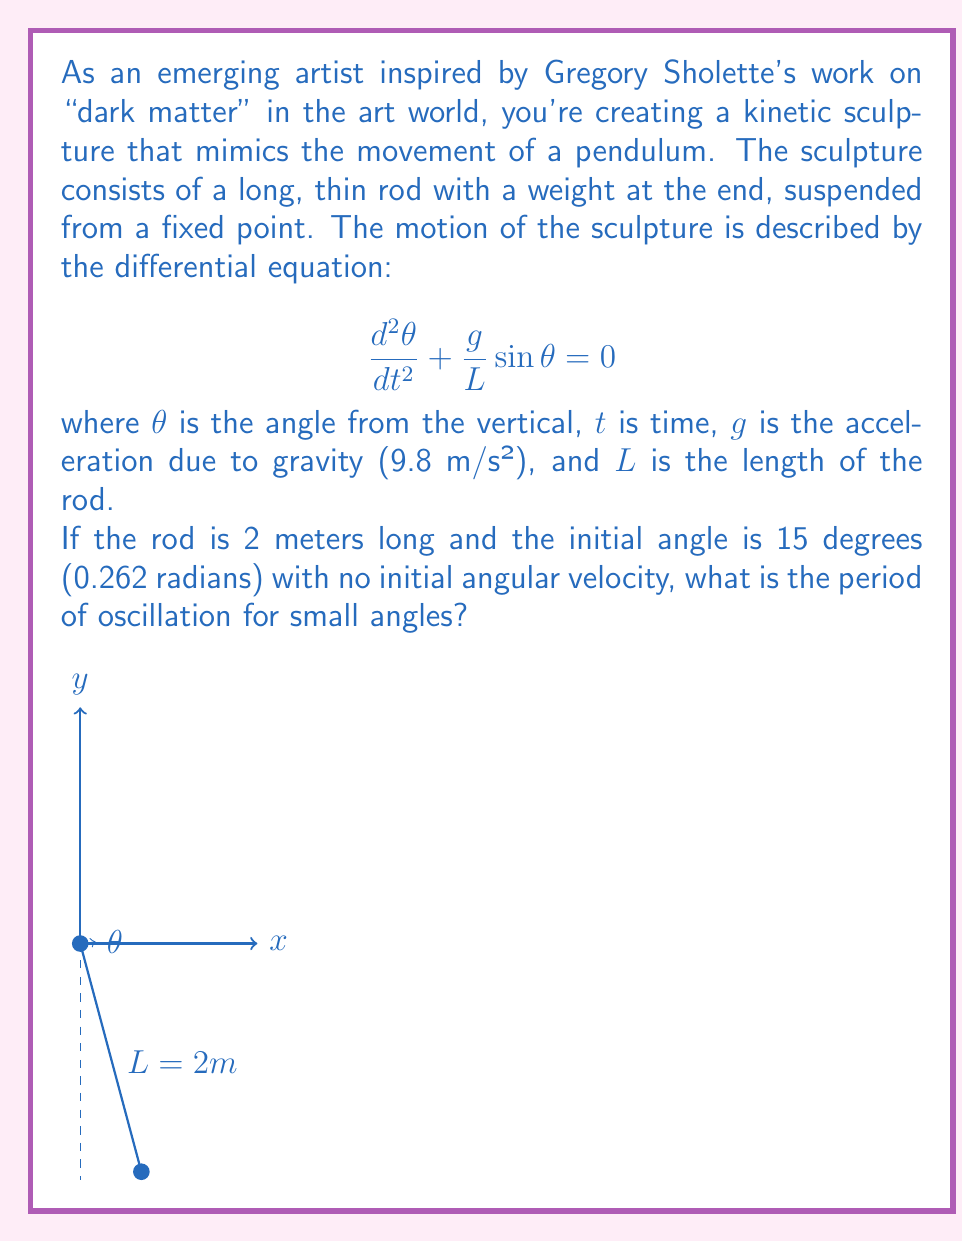Teach me how to tackle this problem. To solve this problem, we'll follow these steps:

1) For small angles, $\sin\theta \approx \theta$, so our equation becomes:

   $$\frac{d^2\theta}{dt^2} + \frac{g}{L}\theta = 0$$

2) This is a simple harmonic oscillator equation of the form:

   $$\frac{d^2\theta}{dt^2} + \omega^2\theta = 0$$

   where $\omega^2 = \frac{g}{L}$

3) The period of oscillation for a simple harmonic oscillator is given by:

   $$T = \frac{2\pi}{\omega} = 2\pi\sqrt{\frac{L}{g}}$$

4) We're given that $L = 2$ meters and $g = 9.8$ m/s². Let's substitute these values:

   $$T = 2\pi\sqrt{\frac{2}{9.8}}$$

5) Simplifying:

   $$T = 2\pi\sqrt{\frac{1}{4.9}} \approx 2.84 \text{ seconds}$$

Note: The initial angle and angular velocity don't affect the period for small oscillations.
Answer: 2.84 seconds 